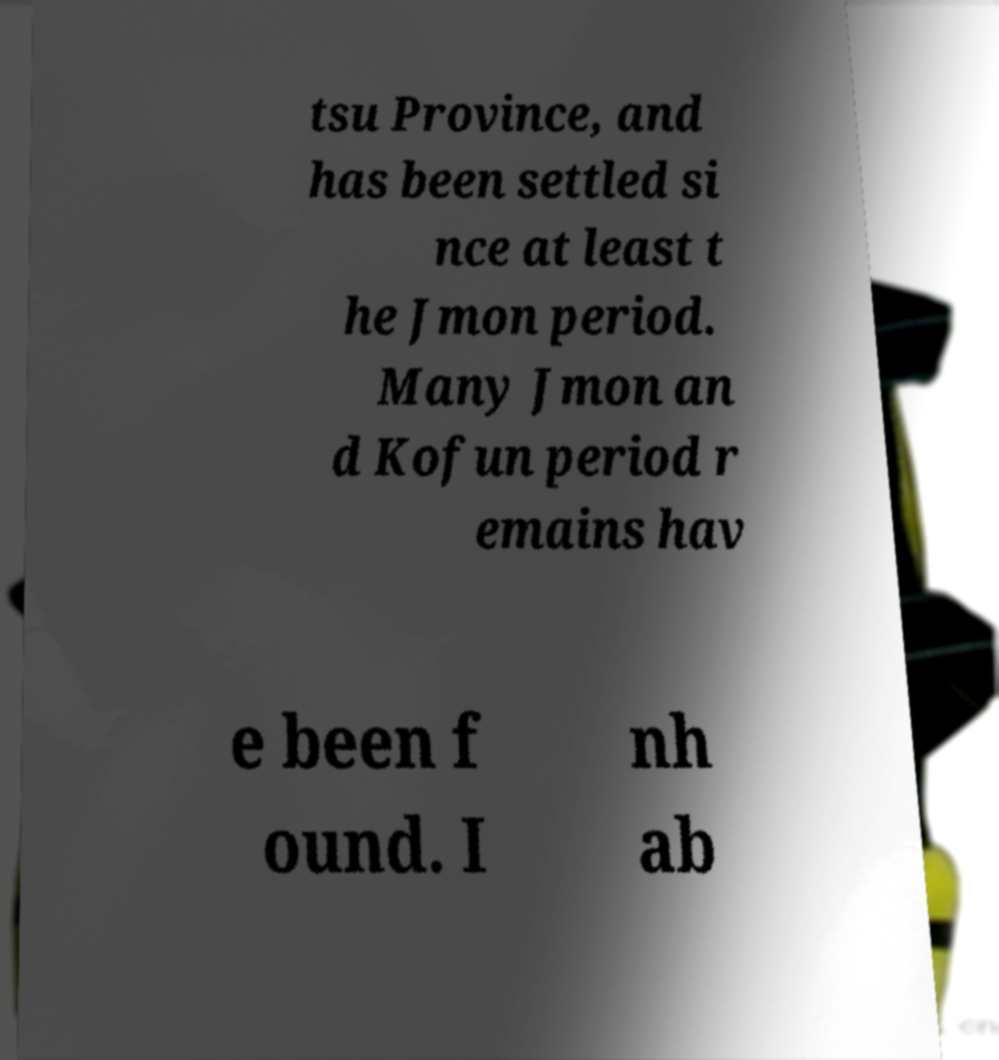I need the written content from this picture converted into text. Can you do that? tsu Province, and has been settled si nce at least t he Jmon period. Many Jmon an d Kofun period r emains hav e been f ound. I nh ab 